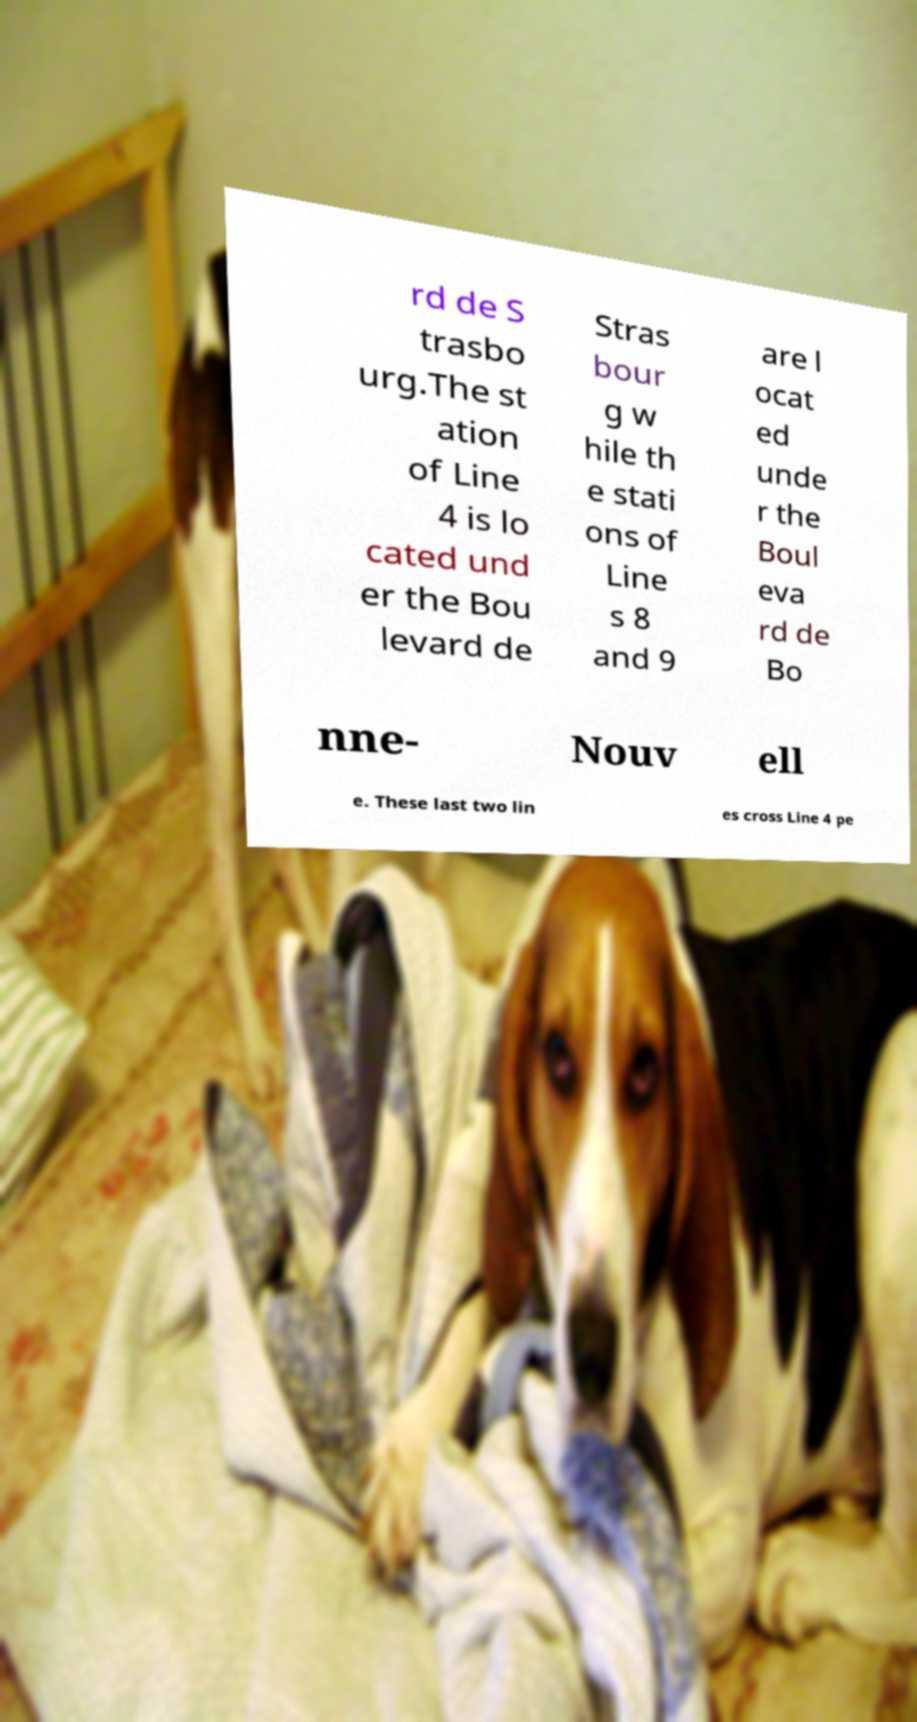Could you extract and type out the text from this image? rd de S trasbo urg.The st ation of Line 4 is lo cated und er the Bou levard de Stras bour g w hile th e stati ons of Line s 8 and 9 are l ocat ed unde r the Boul eva rd de Bo nne- Nouv ell e. These last two lin es cross Line 4 pe 